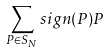Convert formula to latex. <formula><loc_0><loc_0><loc_500><loc_500>\sum _ { P \in S _ { N } } s i g n ( P ) P</formula> 